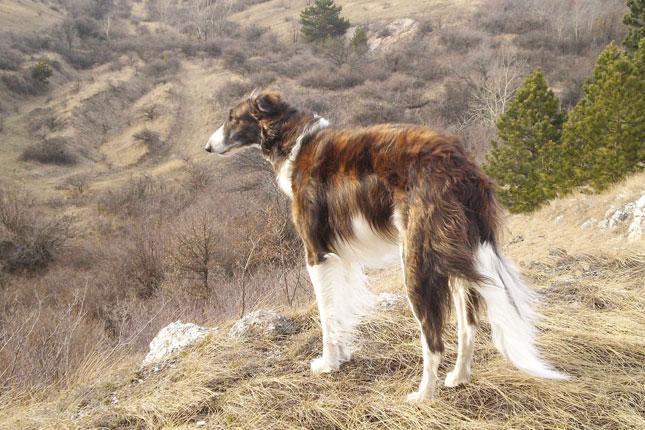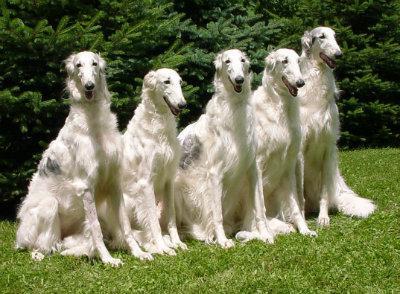The first image is the image on the left, the second image is the image on the right. Evaluate the accuracy of this statement regarding the images: "A woman's legs are seen next to dog.". Is it true? Answer yes or no. No. The first image is the image on the left, the second image is the image on the right. For the images displayed, is the sentence "There is only one dog in the left image and it is looking left." factually correct? Answer yes or no. Yes. 